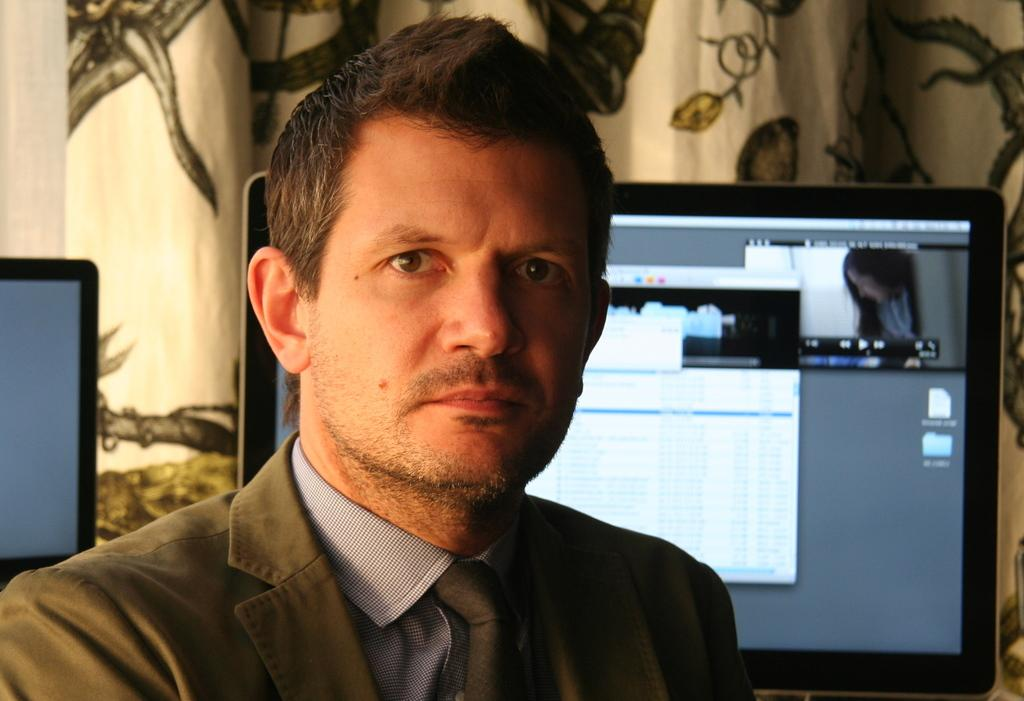Who is present in the image? There is a man in the image. What is the man wearing? The man is wearing a suit. What can be seen in the background of the image? There is a computer in the background of the image. What type of window treatment is present in the image? There is a curtain in the image. What type of club does the woman in the image belong to? There is no woman present in the image, so it is not possible to answer a question about a club she might belong to. 